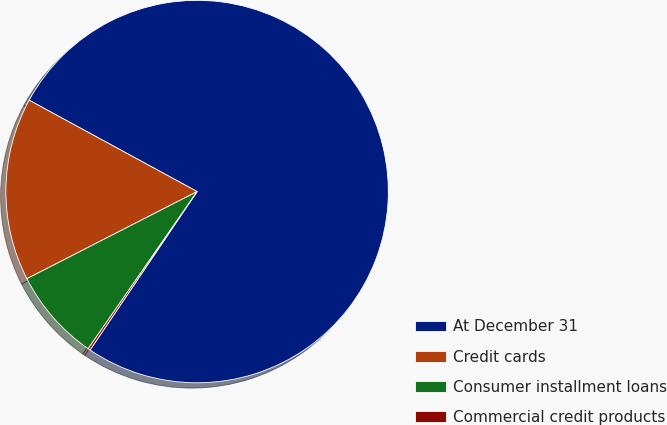Convert chart to OTSL. <chart><loc_0><loc_0><loc_500><loc_500><pie_chart><fcel>At December 31<fcel>Credit cards<fcel>Consumer installment loans<fcel>Commercial credit products<nl><fcel>76.53%<fcel>15.46%<fcel>7.82%<fcel>0.19%<nl></chart> 